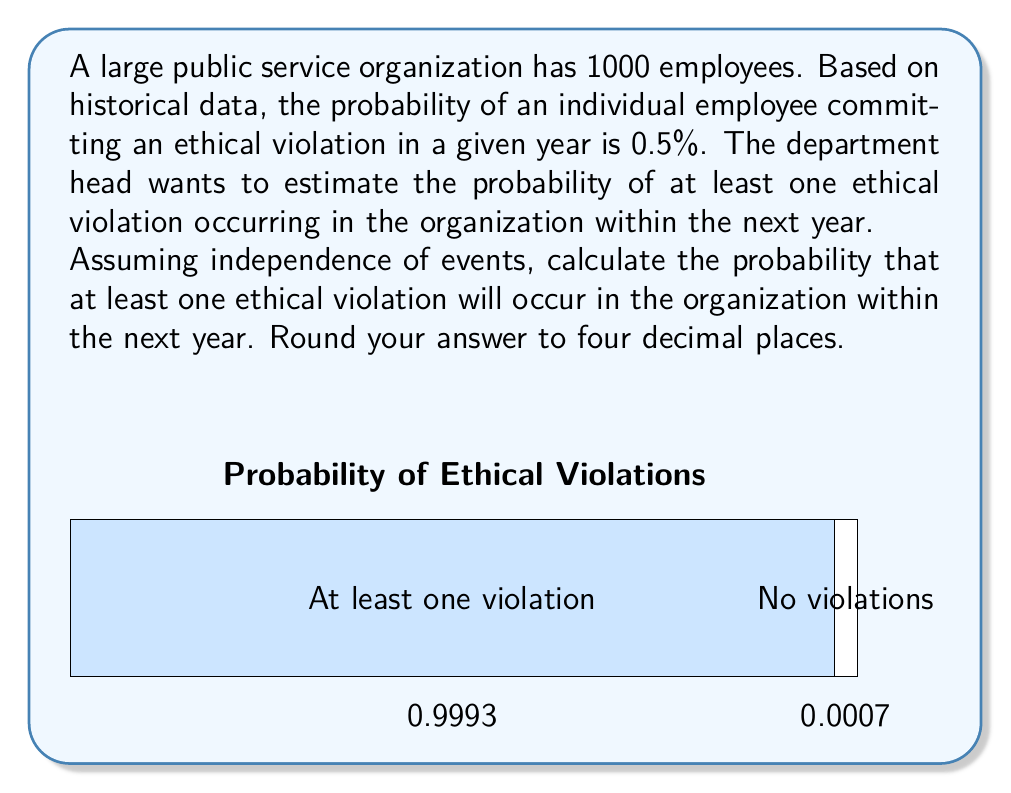Help me with this question. Let's approach this step-by-step:

1) First, let's define our events:
   Let A be the event "at least one ethical violation occurs in the organization within a year"

2) It's easier to calculate the probability of the complement of A, which is "no ethical violations occur"

3) For no violations to occur, each of the 1000 employees must not commit a violation

4) The probability of an employee not committing a violation is:
   $1 - 0.005 = 0.995$

5) Assuming independence, the probability of no violations in the entire organization is:
   $P(\text{no violations}) = (0.995)^{1000}$

6) Therefore, the probability of at least one violation is:
   $P(A) = 1 - P(\text{no violations}) = 1 - (0.995)^{1000}$

7) Let's calculate this:
   $P(A) = 1 - (0.995)^{1000}$
   $    = 1 - 0.0067$
   $    = 0.9933$

8) Rounding to four decimal places:
   $P(A) \approx 0.9933$

This high probability underscores the importance of maintaining strong ethical standards and oversight in large organizations.
Answer: $0.9933$ 